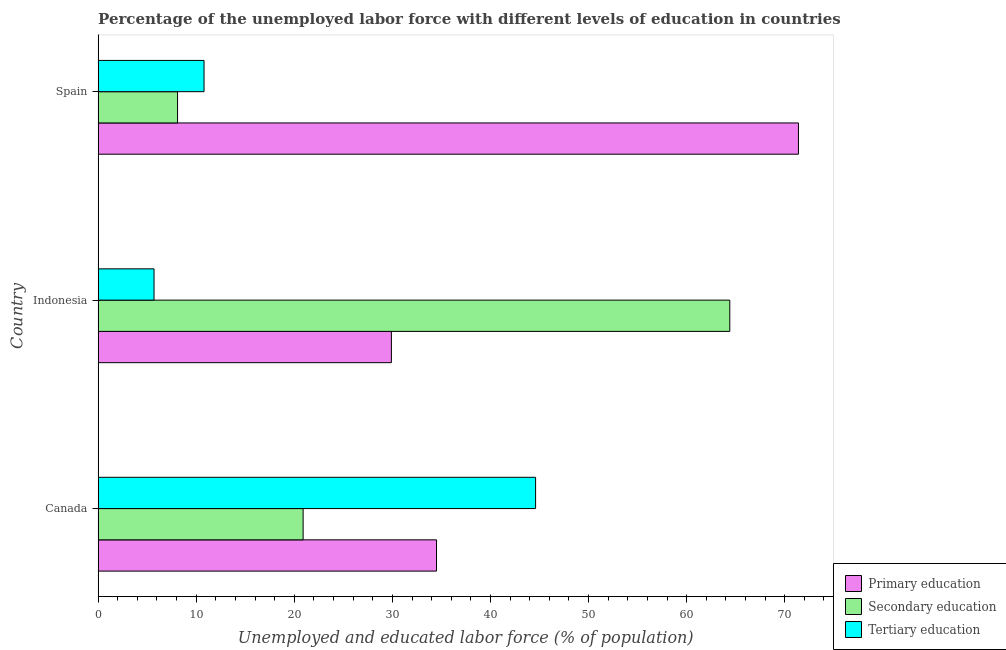How many different coloured bars are there?
Ensure brevity in your answer.  3. Are the number of bars per tick equal to the number of legend labels?
Offer a very short reply. Yes. How many bars are there on the 3rd tick from the top?
Offer a terse response. 3. How many bars are there on the 2nd tick from the bottom?
Provide a short and direct response. 3. In how many cases, is the number of bars for a given country not equal to the number of legend labels?
Give a very brief answer. 0. What is the percentage of labor force who received secondary education in Indonesia?
Ensure brevity in your answer.  64.4. Across all countries, what is the maximum percentage of labor force who received secondary education?
Offer a terse response. 64.4. Across all countries, what is the minimum percentage of labor force who received secondary education?
Offer a terse response. 8.1. In which country was the percentage of labor force who received primary education minimum?
Make the answer very short. Indonesia. What is the total percentage of labor force who received primary education in the graph?
Your answer should be compact. 135.8. What is the difference between the percentage of labor force who received tertiary education in Canada and that in Spain?
Give a very brief answer. 33.8. What is the difference between the percentage of labor force who received secondary education in Indonesia and the percentage of labor force who received tertiary education in Spain?
Your answer should be compact. 53.6. What is the average percentage of labor force who received primary education per country?
Ensure brevity in your answer.  45.27. What is the difference between the percentage of labor force who received secondary education and percentage of labor force who received primary education in Canada?
Offer a very short reply. -13.6. What is the ratio of the percentage of labor force who received secondary education in Indonesia to that in Spain?
Offer a terse response. 7.95. Is the difference between the percentage of labor force who received primary education in Canada and Indonesia greater than the difference between the percentage of labor force who received secondary education in Canada and Indonesia?
Give a very brief answer. Yes. What is the difference between the highest and the second highest percentage of labor force who received tertiary education?
Ensure brevity in your answer.  33.8. What is the difference between the highest and the lowest percentage of labor force who received tertiary education?
Make the answer very short. 38.9. In how many countries, is the percentage of labor force who received primary education greater than the average percentage of labor force who received primary education taken over all countries?
Your answer should be very brief. 1. Is the sum of the percentage of labor force who received secondary education in Indonesia and Spain greater than the maximum percentage of labor force who received tertiary education across all countries?
Give a very brief answer. Yes. What does the 1st bar from the top in Spain represents?
Provide a short and direct response. Tertiary education. What does the 3rd bar from the bottom in Canada represents?
Your answer should be very brief. Tertiary education. How many bars are there?
Your response must be concise. 9. Are all the bars in the graph horizontal?
Offer a very short reply. Yes. What is the difference between two consecutive major ticks on the X-axis?
Offer a very short reply. 10. Where does the legend appear in the graph?
Give a very brief answer. Bottom right. How are the legend labels stacked?
Make the answer very short. Vertical. What is the title of the graph?
Your response must be concise. Percentage of the unemployed labor force with different levels of education in countries. What is the label or title of the X-axis?
Give a very brief answer. Unemployed and educated labor force (% of population). What is the label or title of the Y-axis?
Keep it short and to the point. Country. What is the Unemployed and educated labor force (% of population) of Primary education in Canada?
Ensure brevity in your answer.  34.5. What is the Unemployed and educated labor force (% of population) of Secondary education in Canada?
Give a very brief answer. 20.9. What is the Unemployed and educated labor force (% of population) of Tertiary education in Canada?
Your response must be concise. 44.6. What is the Unemployed and educated labor force (% of population) of Primary education in Indonesia?
Give a very brief answer. 29.9. What is the Unemployed and educated labor force (% of population) in Secondary education in Indonesia?
Your answer should be very brief. 64.4. What is the Unemployed and educated labor force (% of population) of Tertiary education in Indonesia?
Ensure brevity in your answer.  5.7. What is the Unemployed and educated labor force (% of population) of Primary education in Spain?
Offer a terse response. 71.4. What is the Unemployed and educated labor force (% of population) in Secondary education in Spain?
Keep it short and to the point. 8.1. What is the Unemployed and educated labor force (% of population) of Tertiary education in Spain?
Your answer should be very brief. 10.8. Across all countries, what is the maximum Unemployed and educated labor force (% of population) in Primary education?
Offer a terse response. 71.4. Across all countries, what is the maximum Unemployed and educated labor force (% of population) in Secondary education?
Provide a short and direct response. 64.4. Across all countries, what is the maximum Unemployed and educated labor force (% of population) of Tertiary education?
Your answer should be very brief. 44.6. Across all countries, what is the minimum Unemployed and educated labor force (% of population) of Primary education?
Ensure brevity in your answer.  29.9. Across all countries, what is the minimum Unemployed and educated labor force (% of population) in Secondary education?
Give a very brief answer. 8.1. Across all countries, what is the minimum Unemployed and educated labor force (% of population) in Tertiary education?
Your response must be concise. 5.7. What is the total Unemployed and educated labor force (% of population) in Primary education in the graph?
Provide a short and direct response. 135.8. What is the total Unemployed and educated labor force (% of population) in Secondary education in the graph?
Provide a succinct answer. 93.4. What is the total Unemployed and educated labor force (% of population) in Tertiary education in the graph?
Provide a short and direct response. 61.1. What is the difference between the Unemployed and educated labor force (% of population) of Primary education in Canada and that in Indonesia?
Your answer should be compact. 4.6. What is the difference between the Unemployed and educated labor force (% of population) in Secondary education in Canada and that in Indonesia?
Give a very brief answer. -43.5. What is the difference between the Unemployed and educated labor force (% of population) in Tertiary education in Canada and that in Indonesia?
Offer a terse response. 38.9. What is the difference between the Unemployed and educated labor force (% of population) in Primary education in Canada and that in Spain?
Give a very brief answer. -36.9. What is the difference between the Unemployed and educated labor force (% of population) in Secondary education in Canada and that in Spain?
Provide a succinct answer. 12.8. What is the difference between the Unemployed and educated labor force (% of population) of Tertiary education in Canada and that in Spain?
Your response must be concise. 33.8. What is the difference between the Unemployed and educated labor force (% of population) of Primary education in Indonesia and that in Spain?
Provide a short and direct response. -41.5. What is the difference between the Unemployed and educated labor force (% of population) of Secondary education in Indonesia and that in Spain?
Make the answer very short. 56.3. What is the difference between the Unemployed and educated labor force (% of population) of Primary education in Canada and the Unemployed and educated labor force (% of population) of Secondary education in Indonesia?
Keep it short and to the point. -29.9. What is the difference between the Unemployed and educated labor force (% of population) of Primary education in Canada and the Unemployed and educated labor force (% of population) of Tertiary education in Indonesia?
Keep it short and to the point. 28.8. What is the difference between the Unemployed and educated labor force (% of population) of Secondary education in Canada and the Unemployed and educated labor force (% of population) of Tertiary education in Indonesia?
Your answer should be compact. 15.2. What is the difference between the Unemployed and educated labor force (% of population) in Primary education in Canada and the Unemployed and educated labor force (% of population) in Secondary education in Spain?
Provide a short and direct response. 26.4. What is the difference between the Unemployed and educated labor force (% of population) of Primary education in Canada and the Unemployed and educated labor force (% of population) of Tertiary education in Spain?
Keep it short and to the point. 23.7. What is the difference between the Unemployed and educated labor force (% of population) of Primary education in Indonesia and the Unemployed and educated labor force (% of population) of Secondary education in Spain?
Provide a short and direct response. 21.8. What is the difference between the Unemployed and educated labor force (% of population) of Primary education in Indonesia and the Unemployed and educated labor force (% of population) of Tertiary education in Spain?
Your response must be concise. 19.1. What is the difference between the Unemployed and educated labor force (% of population) in Secondary education in Indonesia and the Unemployed and educated labor force (% of population) in Tertiary education in Spain?
Offer a terse response. 53.6. What is the average Unemployed and educated labor force (% of population) of Primary education per country?
Make the answer very short. 45.27. What is the average Unemployed and educated labor force (% of population) of Secondary education per country?
Keep it short and to the point. 31.13. What is the average Unemployed and educated labor force (% of population) in Tertiary education per country?
Provide a short and direct response. 20.37. What is the difference between the Unemployed and educated labor force (% of population) of Primary education and Unemployed and educated labor force (% of population) of Secondary education in Canada?
Give a very brief answer. 13.6. What is the difference between the Unemployed and educated labor force (% of population) of Primary education and Unemployed and educated labor force (% of population) of Tertiary education in Canada?
Your answer should be compact. -10.1. What is the difference between the Unemployed and educated labor force (% of population) of Secondary education and Unemployed and educated labor force (% of population) of Tertiary education in Canada?
Your answer should be very brief. -23.7. What is the difference between the Unemployed and educated labor force (% of population) of Primary education and Unemployed and educated labor force (% of population) of Secondary education in Indonesia?
Provide a short and direct response. -34.5. What is the difference between the Unemployed and educated labor force (% of population) of Primary education and Unemployed and educated labor force (% of population) of Tertiary education in Indonesia?
Make the answer very short. 24.2. What is the difference between the Unemployed and educated labor force (% of population) of Secondary education and Unemployed and educated labor force (% of population) of Tertiary education in Indonesia?
Offer a terse response. 58.7. What is the difference between the Unemployed and educated labor force (% of population) in Primary education and Unemployed and educated labor force (% of population) in Secondary education in Spain?
Offer a very short reply. 63.3. What is the difference between the Unemployed and educated labor force (% of population) in Primary education and Unemployed and educated labor force (% of population) in Tertiary education in Spain?
Offer a terse response. 60.6. What is the ratio of the Unemployed and educated labor force (% of population) in Primary education in Canada to that in Indonesia?
Keep it short and to the point. 1.15. What is the ratio of the Unemployed and educated labor force (% of population) of Secondary education in Canada to that in Indonesia?
Provide a short and direct response. 0.32. What is the ratio of the Unemployed and educated labor force (% of population) in Tertiary education in Canada to that in Indonesia?
Offer a terse response. 7.82. What is the ratio of the Unemployed and educated labor force (% of population) of Primary education in Canada to that in Spain?
Your answer should be compact. 0.48. What is the ratio of the Unemployed and educated labor force (% of population) of Secondary education in Canada to that in Spain?
Offer a very short reply. 2.58. What is the ratio of the Unemployed and educated labor force (% of population) of Tertiary education in Canada to that in Spain?
Keep it short and to the point. 4.13. What is the ratio of the Unemployed and educated labor force (% of population) in Primary education in Indonesia to that in Spain?
Ensure brevity in your answer.  0.42. What is the ratio of the Unemployed and educated labor force (% of population) of Secondary education in Indonesia to that in Spain?
Provide a short and direct response. 7.95. What is the ratio of the Unemployed and educated labor force (% of population) in Tertiary education in Indonesia to that in Spain?
Provide a succinct answer. 0.53. What is the difference between the highest and the second highest Unemployed and educated labor force (% of population) in Primary education?
Make the answer very short. 36.9. What is the difference between the highest and the second highest Unemployed and educated labor force (% of population) of Secondary education?
Provide a short and direct response. 43.5. What is the difference between the highest and the second highest Unemployed and educated labor force (% of population) of Tertiary education?
Provide a short and direct response. 33.8. What is the difference between the highest and the lowest Unemployed and educated labor force (% of population) of Primary education?
Keep it short and to the point. 41.5. What is the difference between the highest and the lowest Unemployed and educated labor force (% of population) of Secondary education?
Offer a very short reply. 56.3. What is the difference between the highest and the lowest Unemployed and educated labor force (% of population) in Tertiary education?
Ensure brevity in your answer.  38.9. 